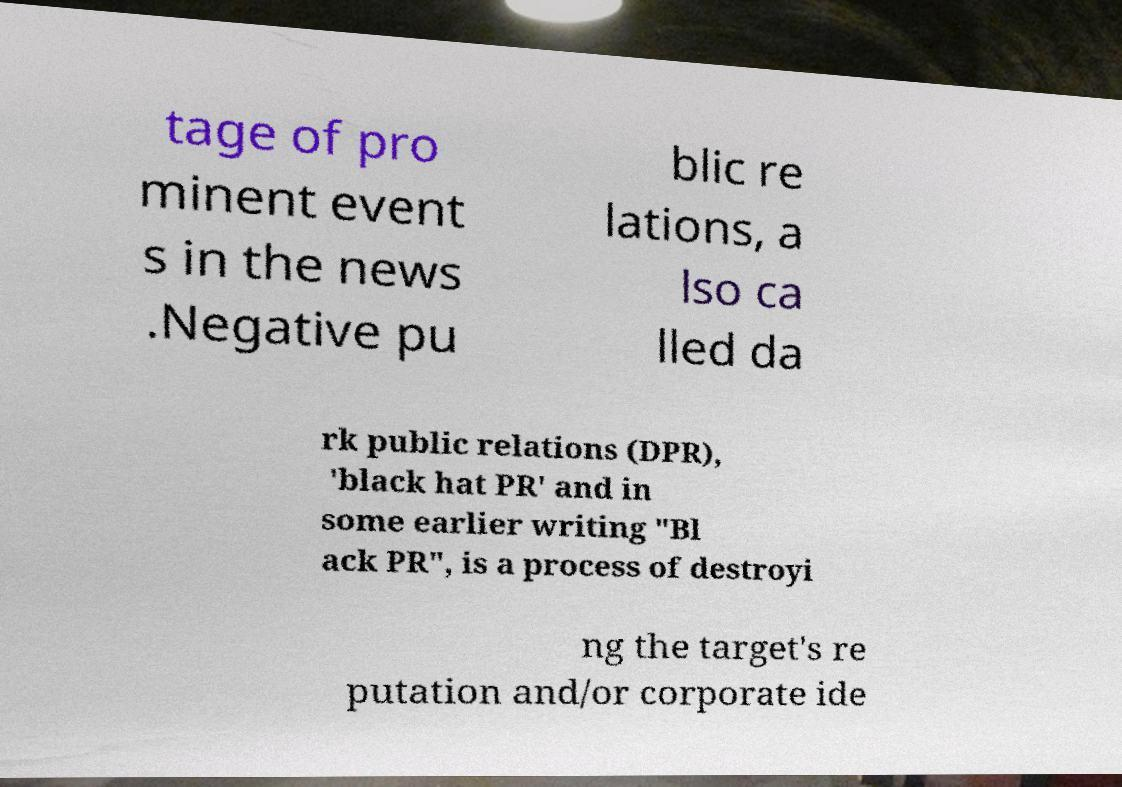Can you accurately transcribe the text from the provided image for me? tage of pro minent event s in the news .Negative pu blic re lations, a lso ca lled da rk public relations (DPR), 'black hat PR' and in some earlier writing "Bl ack PR", is a process of destroyi ng the target's re putation and/or corporate ide 